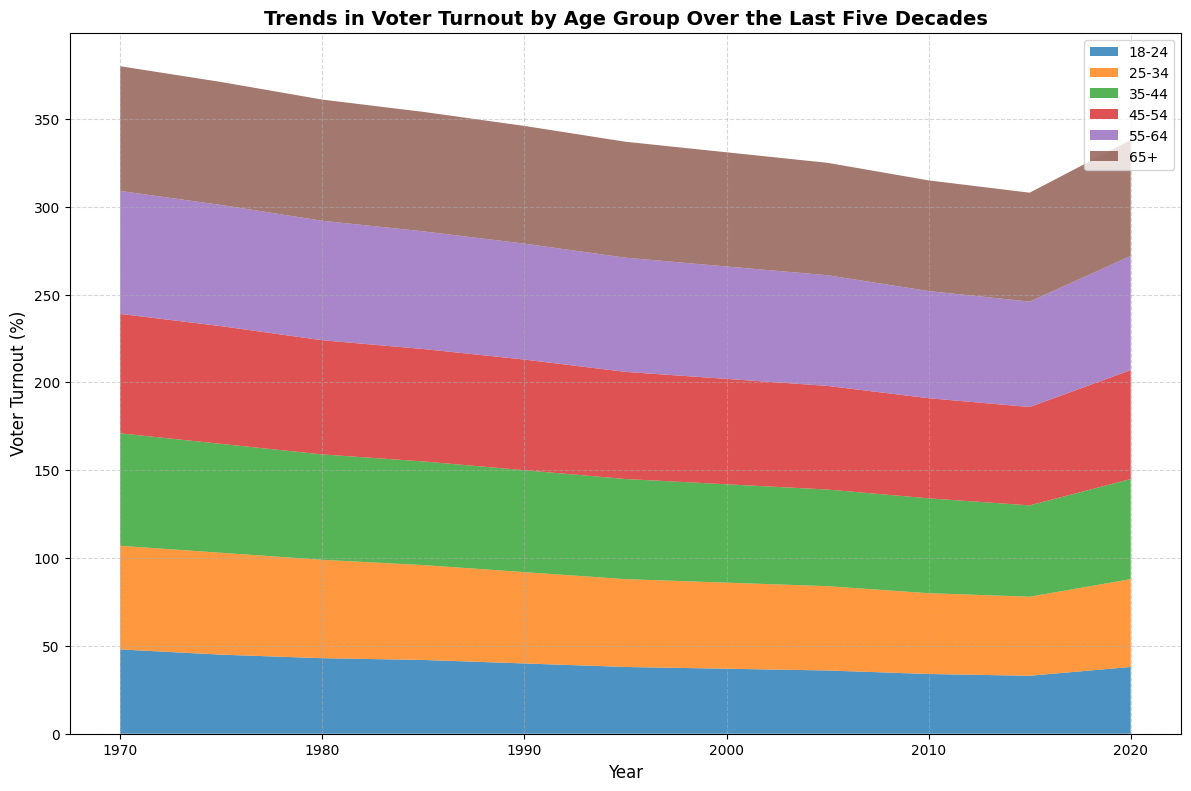What age group had the highest voter turnout in 1970? The plot shows that in 1970, the age group with the highest voter turnout is 65+; the corresponding area for this group in that year is the tallest.
Answer: 65+ How did voter turnout for the 18-24 age group change from 1970 to 2020? According to the plot, the height of the area representing the 18-24 age group has decreased from 48% in 1970 to 38% in 2020.
Answer: Decreased Which age group saw the most consistent decline in voter turnout over the decades? The 18-24 age group shows a consistent decline in the height of its area over the decades from 1970 to 2010, before slightly increasing in 2020.
Answer: 18-24 Compare the voter turnout trends between the 25-34 and 35-44 age groups from 1970 to 2020. The plot shows that both age groups have a general downward trend in voter turnout, but the 35-44 group always has a higher turnout than the 25-34 group throughout the decades.
Answer: 35-44 consistently higher What is the average voter turnout for the 55-64 age group over the decades? To find this, we look at the turnout values for each year for the 55-64 age group: (70 + 69 + 68 + 67 + 66 + 65 + 64 + 63 + 61 + 60 + 65)/11 = 64.
Answer: 64% Which age group showed a resurgence in voter turnout from 2015 to 2020? The plot indicates that the 18-24 age group saw an increase in the height of its area from 33% in 2015 to 38% in 2020.
Answer: 18-24 What percentage difference is there between the voter turnout of the 45-54 and the 65+ age groups in 2020? In 2020, the voter turnout for the 45-54 age group is 62%, and the 65+ age group is 66%. The difference is 66% - 62% = 4%.
Answer: 4% Between which consecutive decades did the 35-44 age group see the steepest turnout decline? By examining the plot, the steepest decline for the 35-44 age group occurs between 1970 (64%) and 1975 (62%).
Answer: Between 1970 and 1975 Compare the voting patterns of the 45-54 age group and the 55-64 age group from 1990 to 2020. The plot shows that both groups have a decreasing trend in voter turnout; however, the 55-64 group consistently has a higher turnout percentage than the 45-54 group in each decade from 1990 to 2020.
Answer: 55-64 higher In which decade did the 65+ age group have the smallest difference from the 55-64 age group's turnout? The smallest difference is observed in 2000, where the turnout for 65+ was 65% and for 55-64 was 64%, resulting in a difference of 1%.
Answer: 2000 